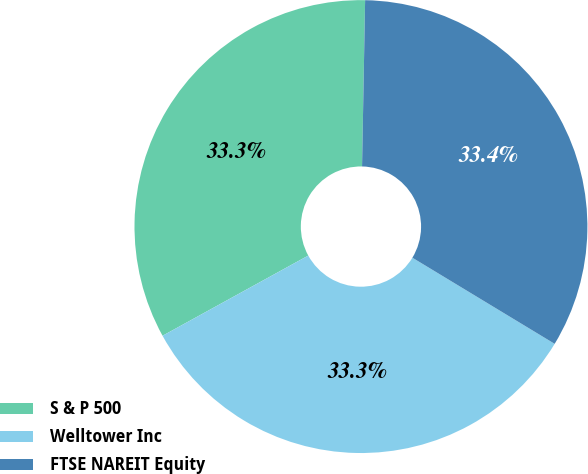<chart> <loc_0><loc_0><loc_500><loc_500><pie_chart><fcel>S & P 500<fcel>Welltower Inc<fcel>FTSE NAREIT Equity<nl><fcel>33.3%<fcel>33.33%<fcel>33.37%<nl></chart> 